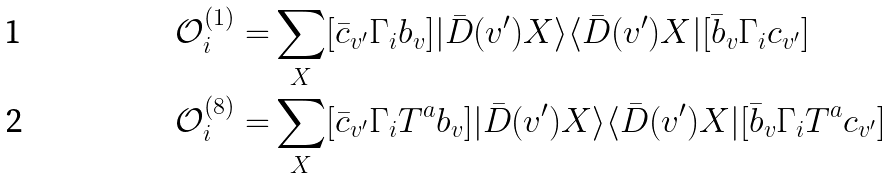Convert formula to latex. <formula><loc_0><loc_0><loc_500><loc_500>\mathcal { O } ^ { ( 1 ) } _ { i } = & \sum _ { X } [ \bar { c } _ { v ^ { \prime } } \Gamma _ { i } b _ { v } ] | \bar { D } ( v ^ { \prime } ) X \rangle \langle \bar { D } ( v ^ { \prime } ) X | [ \bar { b } _ { v } \Gamma _ { i } c _ { v ^ { \prime } } ] \\ \mathcal { O } ^ { ( 8 ) } _ { i } = & \sum _ { X } [ \bar { c } _ { v ^ { \prime } } \Gamma _ { i } T ^ { a } b _ { v } ] | \bar { D } ( v ^ { \prime } ) X \rangle \langle \bar { D } ( v ^ { \prime } ) X | [ \bar { b } _ { v } \Gamma _ { i } T ^ { a } c _ { v ^ { \prime } } ]</formula> 